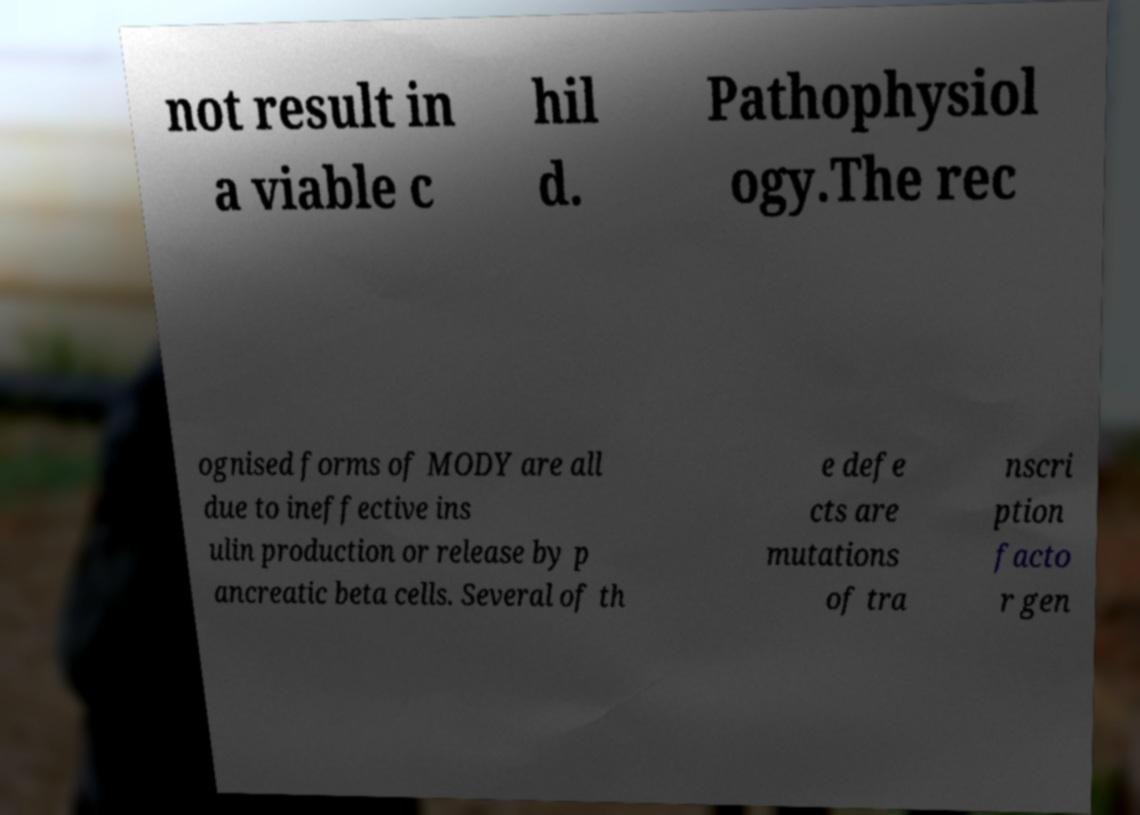There's text embedded in this image that I need extracted. Can you transcribe it verbatim? not result in a viable c hil d. Pathophysiol ogy.The rec ognised forms of MODY are all due to ineffective ins ulin production or release by p ancreatic beta cells. Several of th e defe cts are mutations of tra nscri ption facto r gen 